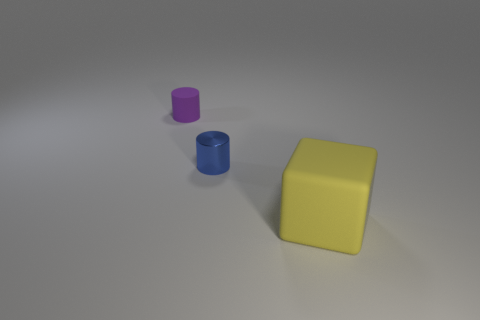Is there any other thing that is the same size as the rubber block?
Ensure brevity in your answer.  No. Are there an equal number of blue things in front of the shiny cylinder and small metal things in front of the large block?
Make the answer very short. Yes. There is a rubber thing that is in front of the blue shiny cylinder; how big is it?
Your answer should be very brief. Large. There is a cylinder behind the small shiny cylinder in front of the small rubber object; what is it made of?
Provide a short and direct response. Rubber. There is a tiny cylinder in front of the thing that is behind the blue thing; how many big objects are to the left of it?
Provide a succinct answer. 0. Are the small object right of the small purple rubber object and the yellow block on the right side of the rubber cylinder made of the same material?
Your response must be concise. No. What number of cyan rubber objects are the same shape as the small blue metallic object?
Your response must be concise. 0. Are there more blue shiny things that are left of the rubber cylinder than big matte blocks?
Keep it short and to the point. No. There is a matte object that is on the right side of the matte object behind the big yellow matte object that is in front of the rubber cylinder; what shape is it?
Your answer should be very brief. Cube. Do the object that is on the left side of the small blue shiny cylinder and the yellow rubber thing that is right of the purple matte thing have the same shape?
Ensure brevity in your answer.  No. 